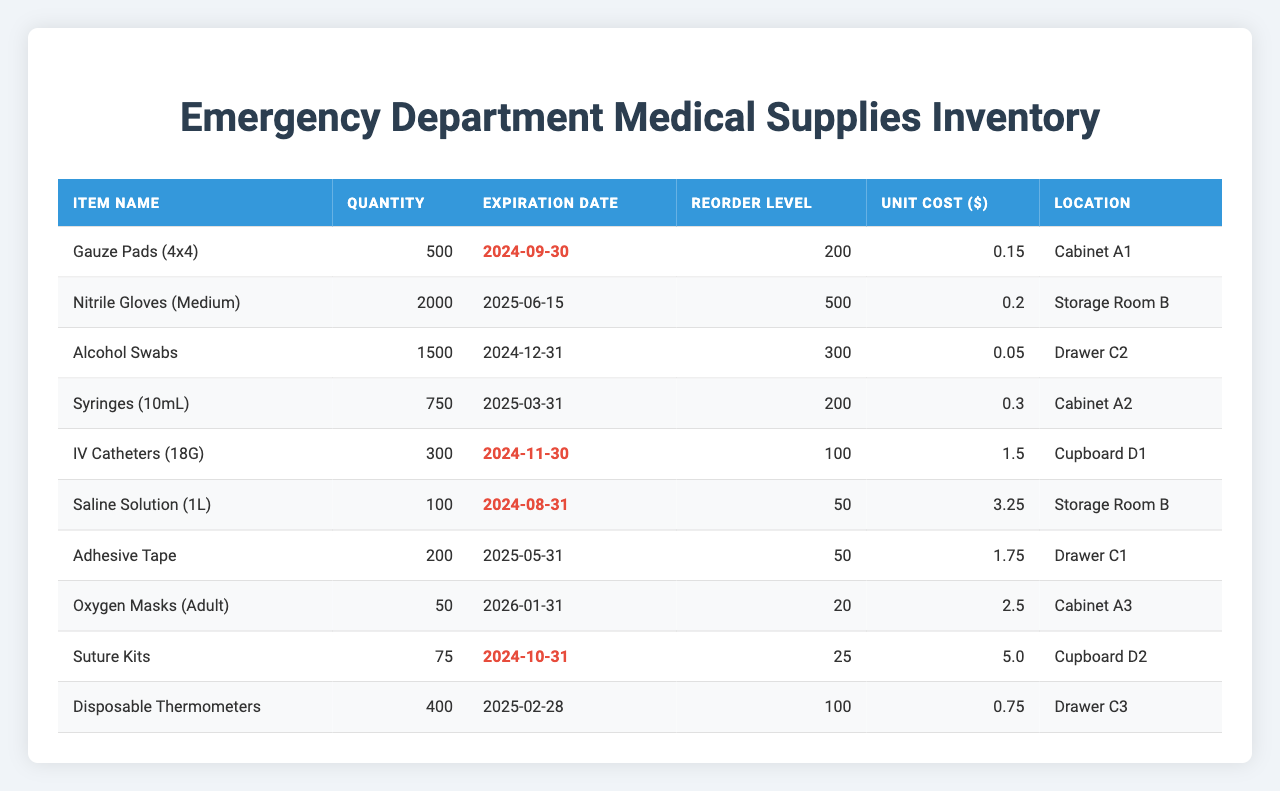What is the total quantity of Nitrile Gloves (Medium) available? The table shows that there are 2000 Nitrile Gloves (Medium) available, making the total quantity for this item 2000.
Answer: 2000 Which item has the lowest quantity? Looking at the quantity column, the item with the lowest quantity is Oxygen Masks (Adult) with a total of 50 units.
Answer: 50 Are there any items that are already at or below their reorder level? Yes, both Saline Solution (1L) with 100 units and Adhesive Tape with 200 units are at or below their respective reorder levels of 50 and 50.
Answer: Yes What is the total unit cost of all IV Catheters (18G) in stock? The table states that there are 300 IV Catheters (18G) and the unit cost is $1.50. Total cost = 300 * 1.50 = $450.
Answer: 450 How many items will expire before the end of 2024? Analyzing the expiration dates, Gauze Pads, Alcohol Swabs, IV Catheters, and Suture Kits will expire before the end of 2024. This counts to 4 items.
Answer: 4 What is the average unit cost of the items listed in the inventory? The unit costs are $0.15, $0.20, $0.05, $0.30, $1.50, $3.25, $1.75, $2.50, $5.00, and $0.75. Adding these gives $15.25. Dividing by 10 items gives an average unit cost of $1.525.
Answer: 1.525 Which items need to be reordered based on their current stock compared to their reorder level? Items that need to be reordered are Saline Solution (1L) as it is at 100, below the reorder level of 50, and Oxygen Masks (Adult) at 50, below the reorder level of 20.
Answer: Saline Solution (1L), Oxygen Masks (Adult) What would be the total cost of replacing all Disposable Thermometers? The table shows that there are 400 Disposable Thermometers, and the unit cost is $0.75. Total cost = 400 * 0.75 = $300.
Answer: 300 Is there an item that will expire in less than three months? Yes, Gauze Pads (4x4) expire on 2024-09-30, which is less than three months away from the current date.
Answer: Yes How many items have a quantity greater than their reorder level? By checking the quantity against the reorder level for each item, it is found that 6 items, including Nitrile Gloves, Alcohol Swabs, and Syringes, have quantities above their reorder levels.
Answer: 6 